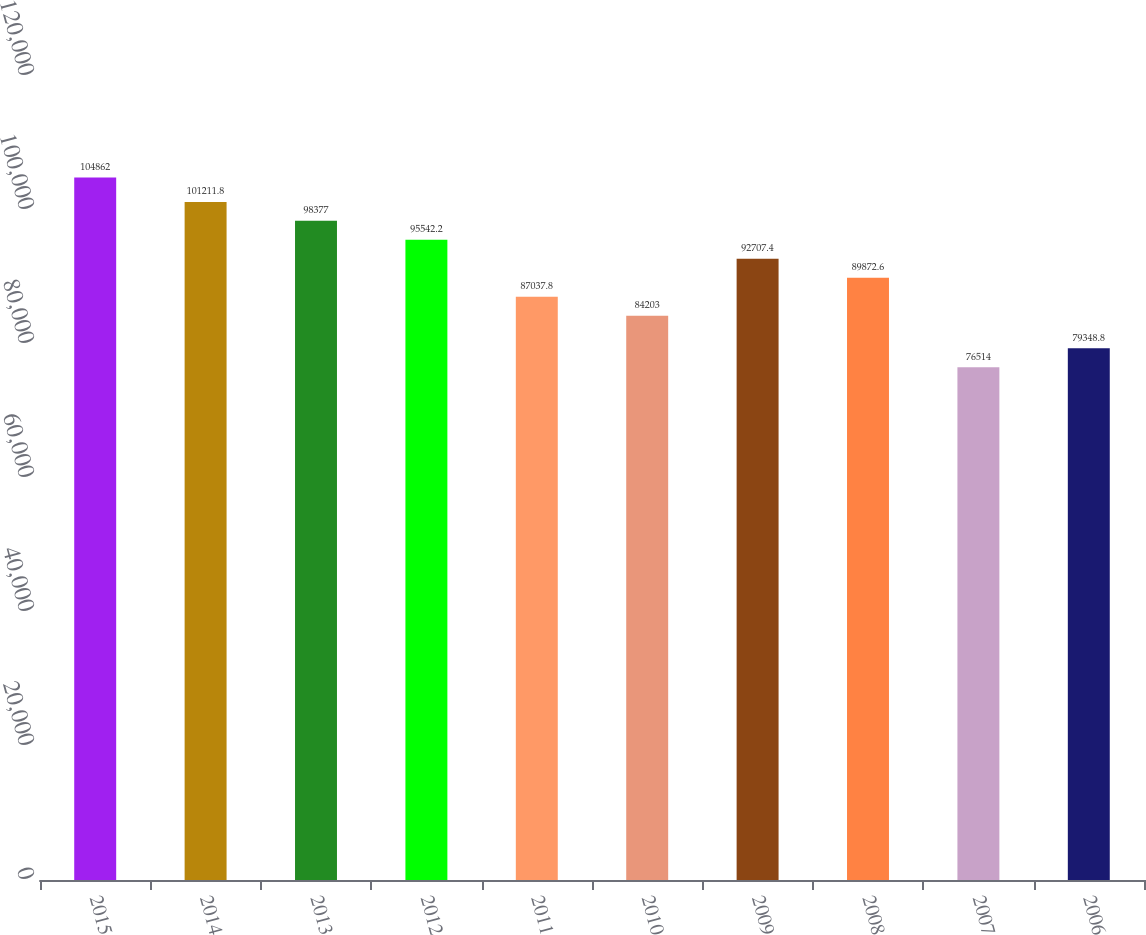<chart> <loc_0><loc_0><loc_500><loc_500><bar_chart><fcel>2015<fcel>2014<fcel>2013<fcel>2012<fcel>2011<fcel>2010<fcel>2009<fcel>2008<fcel>2007<fcel>2006<nl><fcel>104862<fcel>101212<fcel>98377<fcel>95542.2<fcel>87037.8<fcel>84203<fcel>92707.4<fcel>89872.6<fcel>76514<fcel>79348.8<nl></chart> 